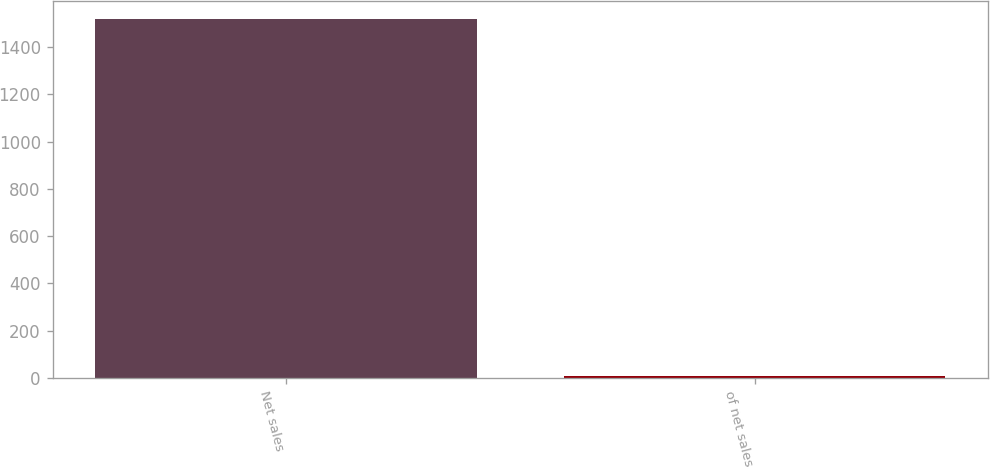<chart> <loc_0><loc_0><loc_500><loc_500><bar_chart><fcel>Net sales<fcel>of net sales<nl><fcel>1521.1<fcel>8.7<nl></chart> 